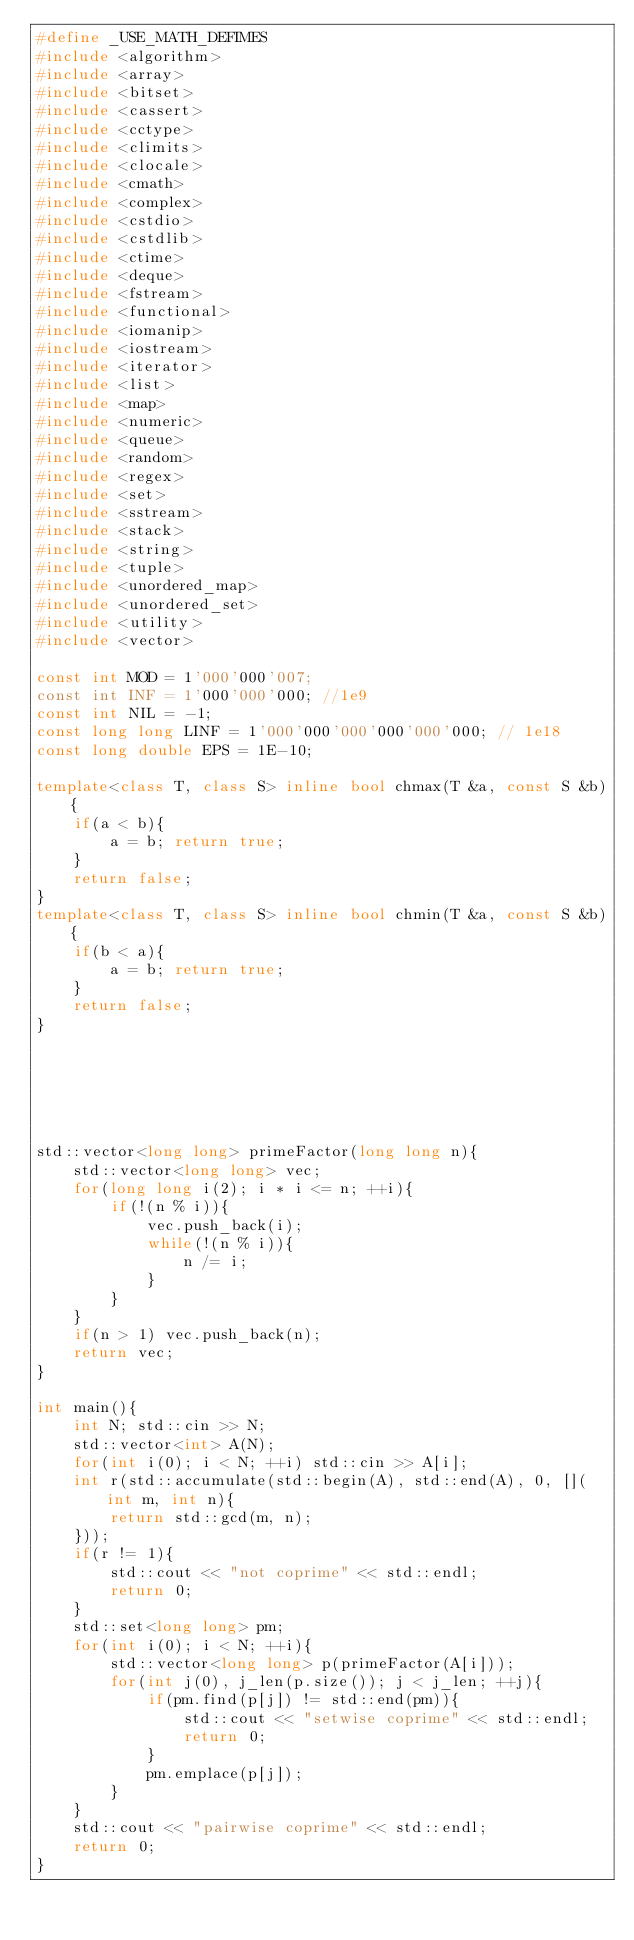Convert code to text. <code><loc_0><loc_0><loc_500><loc_500><_C++_>#define _USE_MATH_DEFIMES
#include <algorithm>
#include <array>
#include <bitset>
#include <cassert>
#include <cctype>
#include <climits>
#include <clocale>
#include <cmath>
#include <complex>
#include <cstdio>
#include <cstdlib>
#include <ctime>
#include <deque>
#include <fstream>
#include <functional>
#include <iomanip>
#include <iostream>
#include <iterator>
#include <list>
#include <map>
#include <numeric>
#include <queue>
#include <random>
#include <regex>
#include <set>
#include <sstream>
#include <stack>
#include <string>
#include <tuple>
#include <unordered_map>
#include <unordered_set>
#include <utility>
#include <vector>

const int MOD = 1'000'000'007;
const int INF = 1'000'000'000; //1e9
const int NIL = -1;
const long long LINF = 1'000'000'000'000'000'000; // 1e18
const long double EPS = 1E-10;

template<class T, class S> inline bool chmax(T &a, const S &b){
    if(a < b){
        a = b; return true;
    }
    return false;
}
template<class T, class S> inline bool chmin(T &a, const S &b){
    if(b < a){
        a = b; return true;
    }
    return false;
}






std::vector<long long> primeFactor(long long n){
    std::vector<long long> vec;
    for(long long i(2); i * i <= n; ++i){
        if(!(n % i)){
            vec.push_back(i);
            while(!(n % i)){
                n /= i;
            }
        }
    }
    if(n > 1) vec.push_back(n);
    return vec;
}

int main(){
    int N; std::cin >> N;
    std::vector<int> A(N);
    for(int i(0); i < N; ++i) std::cin >> A[i];
    int r(std::accumulate(std::begin(A), std::end(A), 0, [](int m, int n){
        return std::gcd(m, n);
    }));
    if(r != 1){
        std::cout << "not coprime" << std::endl;
        return 0;
    }
    std::set<long long> pm;
    for(int i(0); i < N; ++i){
        std::vector<long long> p(primeFactor(A[i]));
        for(int j(0), j_len(p.size()); j < j_len; ++j){
            if(pm.find(p[j]) != std::end(pm)){
                std::cout << "setwise coprime" << std::endl;
                return 0;
            }
            pm.emplace(p[j]);
        }
    }
    std::cout << "pairwise coprime" << std::endl;
    return 0;
}
</code> 